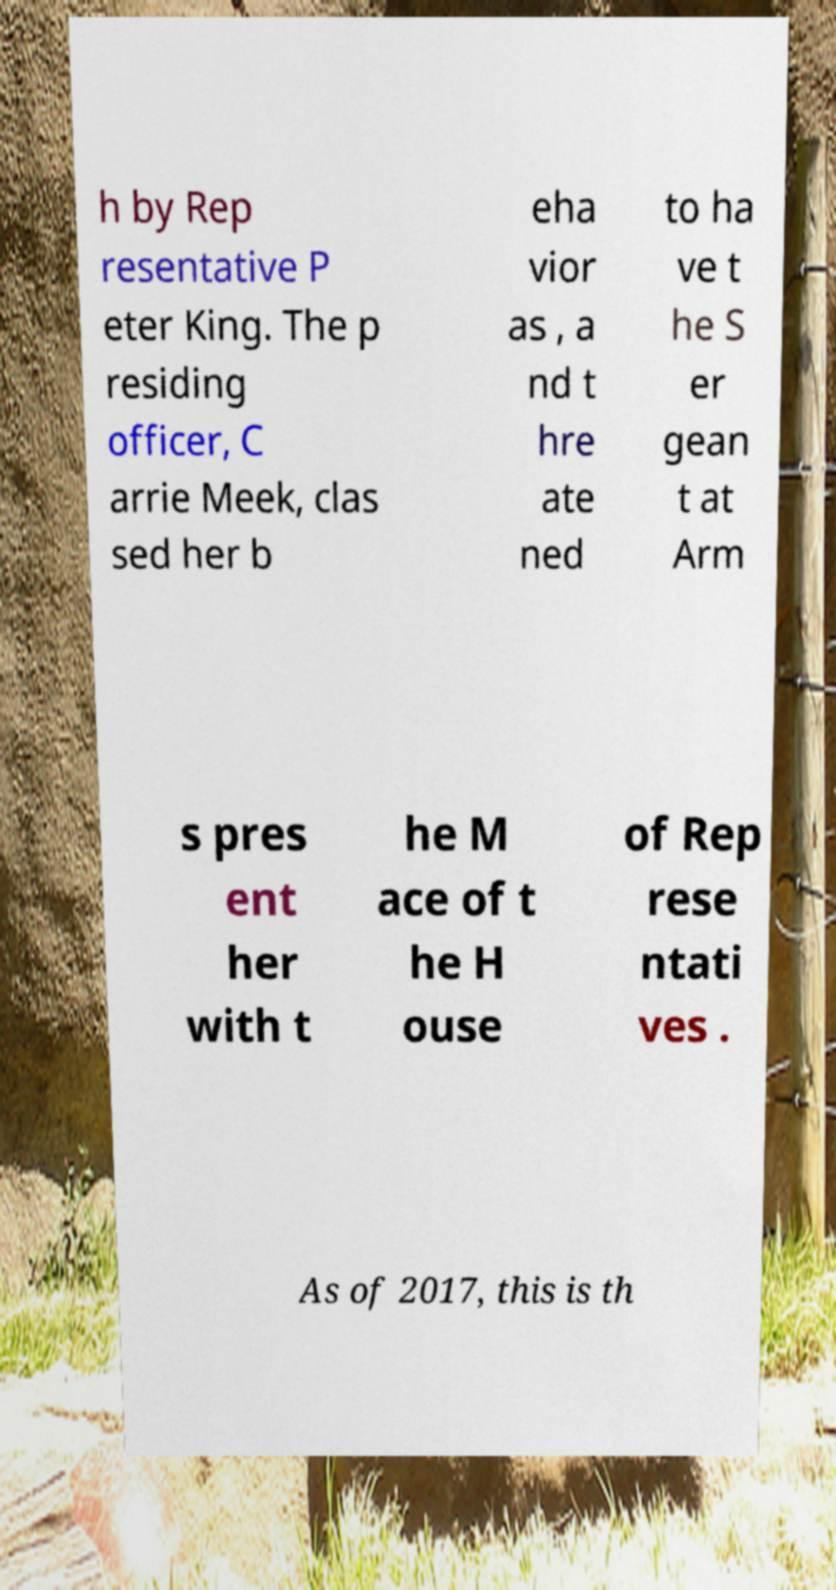What messages or text are displayed in this image? I need them in a readable, typed format. h by Rep resentative P eter King. The p residing officer, C arrie Meek, clas sed her b eha vior as , a nd t hre ate ned to ha ve t he S er gean t at Arm s pres ent her with t he M ace of t he H ouse of Rep rese ntati ves . As of 2017, this is th 